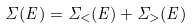Convert formula to latex. <formula><loc_0><loc_0><loc_500><loc_500>\Sigma ( E ) = \Sigma _ { < } ( E ) + \Sigma _ { > } ( E )</formula> 